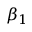<formula> <loc_0><loc_0><loc_500><loc_500>\beta _ { 1 }</formula> 